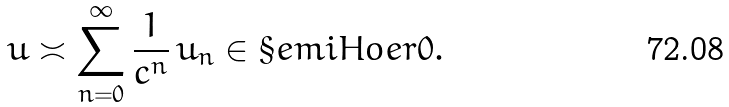<formula> <loc_0><loc_0><loc_500><loc_500>u \asymp \sum _ { n = 0 } ^ { \infty } \frac { 1 } { c ^ { n } } \, u _ { n } \in \S e m i H o e r { 0 } .</formula> 